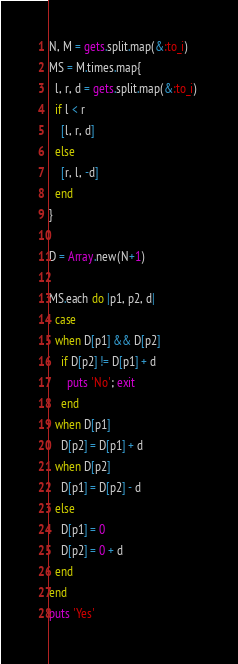Convert code to text. <code><loc_0><loc_0><loc_500><loc_500><_Ruby_>N, M = gets.split.map(&:to_i)
MS = M.times.map{
  l, r, d = gets.split.map(&:to_i) 
  if l < r
    [l, r, d]
  else
    [r, l, -d]
  end
}

D = Array.new(N+1)

MS.each do |p1, p2, d|
  case
  when D[p1] && D[p2]
    if D[p2] != D[p1] + d
      puts 'No'; exit
    end
  when D[p1]
    D[p2] = D[p1] + d
  when D[p2]
    D[p1] = D[p2] - d
  else
    D[p1] = 0
    D[p2] = 0 + d
  end
end
puts 'Yes'
</code> 